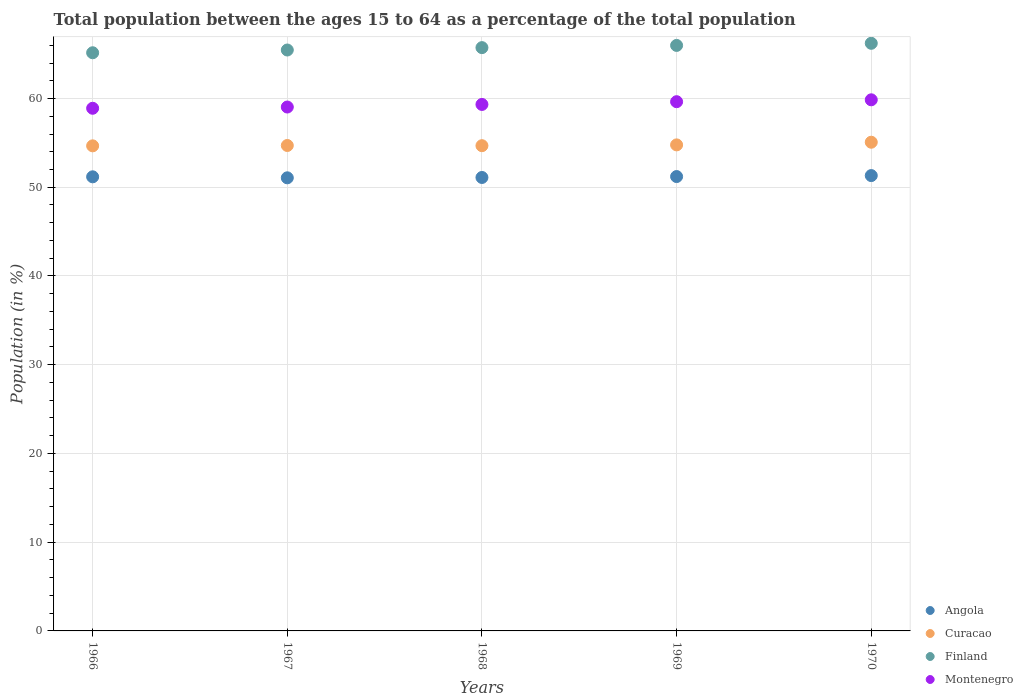How many different coloured dotlines are there?
Provide a short and direct response. 4. What is the percentage of the population ages 15 to 64 in Angola in 1967?
Your answer should be compact. 51.06. Across all years, what is the maximum percentage of the population ages 15 to 64 in Montenegro?
Provide a short and direct response. 59.85. Across all years, what is the minimum percentage of the population ages 15 to 64 in Angola?
Ensure brevity in your answer.  51.06. In which year was the percentage of the population ages 15 to 64 in Angola maximum?
Offer a very short reply. 1970. In which year was the percentage of the population ages 15 to 64 in Finland minimum?
Your answer should be compact. 1966. What is the total percentage of the population ages 15 to 64 in Curacao in the graph?
Ensure brevity in your answer.  273.91. What is the difference between the percentage of the population ages 15 to 64 in Montenegro in 1968 and that in 1969?
Your response must be concise. -0.31. What is the difference between the percentage of the population ages 15 to 64 in Curacao in 1967 and the percentage of the population ages 15 to 64 in Finland in 1970?
Provide a succinct answer. -11.52. What is the average percentage of the population ages 15 to 64 in Curacao per year?
Provide a short and direct response. 54.78. In the year 1967, what is the difference between the percentage of the population ages 15 to 64 in Angola and percentage of the population ages 15 to 64 in Curacao?
Your response must be concise. -3.64. In how many years, is the percentage of the population ages 15 to 64 in Curacao greater than 62?
Your response must be concise. 0. What is the ratio of the percentage of the population ages 15 to 64 in Curacao in 1967 to that in 1970?
Offer a terse response. 0.99. Is the percentage of the population ages 15 to 64 in Montenegro in 1968 less than that in 1970?
Your response must be concise. Yes. What is the difference between the highest and the second highest percentage of the population ages 15 to 64 in Angola?
Provide a succinct answer. 0.11. What is the difference between the highest and the lowest percentage of the population ages 15 to 64 in Finland?
Keep it short and to the point. 1.07. In how many years, is the percentage of the population ages 15 to 64 in Curacao greater than the average percentage of the population ages 15 to 64 in Curacao taken over all years?
Your response must be concise. 1. Is it the case that in every year, the sum of the percentage of the population ages 15 to 64 in Finland and percentage of the population ages 15 to 64 in Angola  is greater than the sum of percentage of the population ages 15 to 64 in Curacao and percentage of the population ages 15 to 64 in Montenegro?
Offer a very short reply. Yes. Is it the case that in every year, the sum of the percentage of the population ages 15 to 64 in Angola and percentage of the population ages 15 to 64 in Finland  is greater than the percentage of the population ages 15 to 64 in Montenegro?
Your answer should be very brief. Yes. Does the percentage of the population ages 15 to 64 in Angola monotonically increase over the years?
Ensure brevity in your answer.  No. Is the percentage of the population ages 15 to 64 in Montenegro strictly greater than the percentage of the population ages 15 to 64 in Angola over the years?
Your answer should be compact. Yes. How many dotlines are there?
Keep it short and to the point. 4. How many years are there in the graph?
Provide a succinct answer. 5. What is the difference between two consecutive major ticks on the Y-axis?
Offer a terse response. 10. Does the graph contain any zero values?
Give a very brief answer. No. Does the graph contain grids?
Give a very brief answer. Yes. Where does the legend appear in the graph?
Your answer should be very brief. Bottom right. How many legend labels are there?
Provide a succinct answer. 4. What is the title of the graph?
Give a very brief answer. Total population between the ages 15 to 64 as a percentage of the total population. What is the Population (in %) in Angola in 1966?
Provide a succinct answer. 51.18. What is the Population (in %) in Curacao in 1966?
Your answer should be very brief. 54.67. What is the Population (in %) of Finland in 1966?
Keep it short and to the point. 65.16. What is the Population (in %) in Montenegro in 1966?
Your response must be concise. 58.9. What is the Population (in %) of Angola in 1967?
Make the answer very short. 51.06. What is the Population (in %) in Curacao in 1967?
Your answer should be compact. 54.71. What is the Population (in %) in Finland in 1967?
Your answer should be compact. 65.47. What is the Population (in %) of Montenegro in 1967?
Give a very brief answer. 59.04. What is the Population (in %) of Angola in 1968?
Offer a terse response. 51.1. What is the Population (in %) in Curacao in 1968?
Provide a succinct answer. 54.68. What is the Population (in %) of Finland in 1968?
Give a very brief answer. 65.74. What is the Population (in %) in Montenegro in 1968?
Provide a short and direct response. 59.33. What is the Population (in %) of Angola in 1969?
Provide a short and direct response. 51.21. What is the Population (in %) in Curacao in 1969?
Provide a succinct answer. 54.78. What is the Population (in %) of Finland in 1969?
Ensure brevity in your answer.  65.98. What is the Population (in %) in Montenegro in 1969?
Provide a succinct answer. 59.64. What is the Population (in %) in Angola in 1970?
Ensure brevity in your answer.  51.32. What is the Population (in %) of Curacao in 1970?
Provide a short and direct response. 55.07. What is the Population (in %) in Finland in 1970?
Keep it short and to the point. 66.22. What is the Population (in %) of Montenegro in 1970?
Offer a terse response. 59.85. Across all years, what is the maximum Population (in %) in Angola?
Your answer should be compact. 51.32. Across all years, what is the maximum Population (in %) in Curacao?
Give a very brief answer. 55.07. Across all years, what is the maximum Population (in %) in Finland?
Your response must be concise. 66.22. Across all years, what is the maximum Population (in %) of Montenegro?
Provide a succinct answer. 59.85. Across all years, what is the minimum Population (in %) of Angola?
Make the answer very short. 51.06. Across all years, what is the minimum Population (in %) in Curacao?
Offer a terse response. 54.67. Across all years, what is the minimum Population (in %) of Finland?
Give a very brief answer. 65.16. Across all years, what is the minimum Population (in %) of Montenegro?
Provide a short and direct response. 58.9. What is the total Population (in %) of Angola in the graph?
Your response must be concise. 255.86. What is the total Population (in %) in Curacao in the graph?
Keep it short and to the point. 273.91. What is the total Population (in %) of Finland in the graph?
Your answer should be compact. 328.57. What is the total Population (in %) in Montenegro in the graph?
Make the answer very short. 296.77. What is the difference between the Population (in %) of Angola in 1966 and that in 1967?
Provide a succinct answer. 0.11. What is the difference between the Population (in %) of Curacao in 1966 and that in 1967?
Your answer should be very brief. -0.04. What is the difference between the Population (in %) of Finland in 1966 and that in 1967?
Make the answer very short. -0.31. What is the difference between the Population (in %) in Montenegro in 1966 and that in 1967?
Ensure brevity in your answer.  -0.14. What is the difference between the Population (in %) of Angola in 1966 and that in 1968?
Your answer should be very brief. 0.07. What is the difference between the Population (in %) in Curacao in 1966 and that in 1968?
Offer a very short reply. -0.02. What is the difference between the Population (in %) in Finland in 1966 and that in 1968?
Keep it short and to the point. -0.58. What is the difference between the Population (in %) of Montenegro in 1966 and that in 1968?
Provide a short and direct response. -0.43. What is the difference between the Population (in %) of Angola in 1966 and that in 1969?
Provide a succinct answer. -0.03. What is the difference between the Population (in %) of Curacao in 1966 and that in 1969?
Ensure brevity in your answer.  -0.11. What is the difference between the Population (in %) of Finland in 1966 and that in 1969?
Your answer should be compact. -0.83. What is the difference between the Population (in %) of Montenegro in 1966 and that in 1969?
Provide a succinct answer. -0.74. What is the difference between the Population (in %) in Angola in 1966 and that in 1970?
Provide a short and direct response. -0.14. What is the difference between the Population (in %) of Curacao in 1966 and that in 1970?
Your response must be concise. -0.41. What is the difference between the Population (in %) in Finland in 1966 and that in 1970?
Keep it short and to the point. -1.07. What is the difference between the Population (in %) in Montenegro in 1966 and that in 1970?
Provide a short and direct response. -0.95. What is the difference between the Population (in %) in Angola in 1967 and that in 1968?
Make the answer very short. -0.04. What is the difference between the Population (in %) in Curacao in 1967 and that in 1968?
Provide a short and direct response. 0.02. What is the difference between the Population (in %) in Finland in 1967 and that in 1968?
Your answer should be very brief. -0.27. What is the difference between the Population (in %) of Montenegro in 1967 and that in 1968?
Provide a succinct answer. -0.29. What is the difference between the Population (in %) of Angola in 1967 and that in 1969?
Your answer should be compact. -0.14. What is the difference between the Population (in %) in Curacao in 1967 and that in 1969?
Make the answer very short. -0.07. What is the difference between the Population (in %) in Finland in 1967 and that in 1969?
Keep it short and to the point. -0.52. What is the difference between the Population (in %) in Montenegro in 1967 and that in 1969?
Your answer should be very brief. -0.6. What is the difference between the Population (in %) of Angola in 1967 and that in 1970?
Give a very brief answer. -0.25. What is the difference between the Population (in %) of Curacao in 1967 and that in 1970?
Your answer should be very brief. -0.37. What is the difference between the Population (in %) of Finland in 1967 and that in 1970?
Give a very brief answer. -0.76. What is the difference between the Population (in %) in Montenegro in 1967 and that in 1970?
Ensure brevity in your answer.  -0.81. What is the difference between the Population (in %) of Angola in 1968 and that in 1969?
Make the answer very short. -0.1. What is the difference between the Population (in %) of Curacao in 1968 and that in 1969?
Give a very brief answer. -0.09. What is the difference between the Population (in %) of Finland in 1968 and that in 1969?
Make the answer very short. -0.25. What is the difference between the Population (in %) of Montenegro in 1968 and that in 1969?
Keep it short and to the point. -0.31. What is the difference between the Population (in %) in Angola in 1968 and that in 1970?
Your answer should be compact. -0.21. What is the difference between the Population (in %) in Curacao in 1968 and that in 1970?
Offer a terse response. -0.39. What is the difference between the Population (in %) in Finland in 1968 and that in 1970?
Your answer should be compact. -0.49. What is the difference between the Population (in %) of Montenegro in 1968 and that in 1970?
Ensure brevity in your answer.  -0.52. What is the difference between the Population (in %) in Angola in 1969 and that in 1970?
Offer a terse response. -0.11. What is the difference between the Population (in %) in Curacao in 1969 and that in 1970?
Your response must be concise. -0.3. What is the difference between the Population (in %) in Finland in 1969 and that in 1970?
Make the answer very short. -0.24. What is the difference between the Population (in %) in Montenegro in 1969 and that in 1970?
Provide a succinct answer. -0.21. What is the difference between the Population (in %) of Angola in 1966 and the Population (in %) of Curacao in 1967?
Make the answer very short. -3.53. What is the difference between the Population (in %) in Angola in 1966 and the Population (in %) in Finland in 1967?
Provide a succinct answer. -14.29. What is the difference between the Population (in %) in Angola in 1966 and the Population (in %) in Montenegro in 1967?
Your response must be concise. -7.87. What is the difference between the Population (in %) in Curacao in 1966 and the Population (in %) in Finland in 1967?
Provide a short and direct response. -10.8. What is the difference between the Population (in %) of Curacao in 1966 and the Population (in %) of Montenegro in 1967?
Offer a very short reply. -4.37. What is the difference between the Population (in %) in Finland in 1966 and the Population (in %) in Montenegro in 1967?
Give a very brief answer. 6.12. What is the difference between the Population (in %) of Angola in 1966 and the Population (in %) of Curacao in 1968?
Provide a short and direct response. -3.51. What is the difference between the Population (in %) in Angola in 1966 and the Population (in %) in Finland in 1968?
Your response must be concise. -14.56. What is the difference between the Population (in %) in Angola in 1966 and the Population (in %) in Montenegro in 1968?
Keep it short and to the point. -8.16. What is the difference between the Population (in %) of Curacao in 1966 and the Population (in %) of Finland in 1968?
Your answer should be very brief. -11.07. What is the difference between the Population (in %) in Curacao in 1966 and the Population (in %) in Montenegro in 1968?
Your response must be concise. -4.67. What is the difference between the Population (in %) in Finland in 1966 and the Population (in %) in Montenegro in 1968?
Offer a terse response. 5.82. What is the difference between the Population (in %) of Angola in 1966 and the Population (in %) of Curacao in 1969?
Provide a short and direct response. -3.6. What is the difference between the Population (in %) in Angola in 1966 and the Population (in %) in Finland in 1969?
Ensure brevity in your answer.  -14.81. What is the difference between the Population (in %) in Angola in 1966 and the Population (in %) in Montenegro in 1969?
Offer a very short reply. -8.47. What is the difference between the Population (in %) in Curacao in 1966 and the Population (in %) in Finland in 1969?
Ensure brevity in your answer.  -11.32. What is the difference between the Population (in %) in Curacao in 1966 and the Population (in %) in Montenegro in 1969?
Keep it short and to the point. -4.97. What is the difference between the Population (in %) in Finland in 1966 and the Population (in %) in Montenegro in 1969?
Offer a terse response. 5.52. What is the difference between the Population (in %) in Angola in 1966 and the Population (in %) in Curacao in 1970?
Give a very brief answer. -3.9. What is the difference between the Population (in %) of Angola in 1966 and the Population (in %) of Finland in 1970?
Your answer should be very brief. -15.05. What is the difference between the Population (in %) of Angola in 1966 and the Population (in %) of Montenegro in 1970?
Keep it short and to the point. -8.68. What is the difference between the Population (in %) in Curacao in 1966 and the Population (in %) in Finland in 1970?
Your answer should be compact. -11.56. What is the difference between the Population (in %) in Curacao in 1966 and the Population (in %) in Montenegro in 1970?
Ensure brevity in your answer.  -5.19. What is the difference between the Population (in %) in Finland in 1966 and the Population (in %) in Montenegro in 1970?
Your answer should be very brief. 5.3. What is the difference between the Population (in %) of Angola in 1967 and the Population (in %) of Curacao in 1968?
Give a very brief answer. -3.62. What is the difference between the Population (in %) of Angola in 1967 and the Population (in %) of Finland in 1968?
Make the answer very short. -14.67. What is the difference between the Population (in %) in Angola in 1967 and the Population (in %) in Montenegro in 1968?
Your response must be concise. -8.27. What is the difference between the Population (in %) in Curacao in 1967 and the Population (in %) in Finland in 1968?
Keep it short and to the point. -11.03. What is the difference between the Population (in %) in Curacao in 1967 and the Population (in %) in Montenegro in 1968?
Offer a terse response. -4.63. What is the difference between the Population (in %) of Finland in 1967 and the Population (in %) of Montenegro in 1968?
Ensure brevity in your answer.  6.13. What is the difference between the Population (in %) in Angola in 1967 and the Population (in %) in Curacao in 1969?
Your answer should be compact. -3.71. What is the difference between the Population (in %) of Angola in 1967 and the Population (in %) of Finland in 1969?
Provide a succinct answer. -14.92. What is the difference between the Population (in %) in Angola in 1967 and the Population (in %) in Montenegro in 1969?
Give a very brief answer. -8.58. What is the difference between the Population (in %) in Curacao in 1967 and the Population (in %) in Finland in 1969?
Ensure brevity in your answer.  -11.28. What is the difference between the Population (in %) of Curacao in 1967 and the Population (in %) of Montenegro in 1969?
Make the answer very short. -4.94. What is the difference between the Population (in %) of Finland in 1967 and the Population (in %) of Montenegro in 1969?
Your answer should be compact. 5.83. What is the difference between the Population (in %) in Angola in 1967 and the Population (in %) in Curacao in 1970?
Offer a very short reply. -4.01. What is the difference between the Population (in %) of Angola in 1967 and the Population (in %) of Finland in 1970?
Provide a succinct answer. -15.16. What is the difference between the Population (in %) in Angola in 1967 and the Population (in %) in Montenegro in 1970?
Keep it short and to the point. -8.79. What is the difference between the Population (in %) in Curacao in 1967 and the Population (in %) in Finland in 1970?
Your answer should be compact. -11.52. What is the difference between the Population (in %) of Curacao in 1967 and the Population (in %) of Montenegro in 1970?
Your response must be concise. -5.15. What is the difference between the Population (in %) in Finland in 1967 and the Population (in %) in Montenegro in 1970?
Ensure brevity in your answer.  5.61. What is the difference between the Population (in %) of Angola in 1968 and the Population (in %) of Curacao in 1969?
Keep it short and to the point. -3.67. What is the difference between the Population (in %) of Angola in 1968 and the Population (in %) of Finland in 1969?
Ensure brevity in your answer.  -14.88. What is the difference between the Population (in %) of Angola in 1968 and the Population (in %) of Montenegro in 1969?
Your response must be concise. -8.54. What is the difference between the Population (in %) of Curacao in 1968 and the Population (in %) of Finland in 1969?
Your answer should be compact. -11.3. What is the difference between the Population (in %) in Curacao in 1968 and the Population (in %) in Montenegro in 1969?
Your answer should be very brief. -4.96. What is the difference between the Population (in %) of Finland in 1968 and the Population (in %) of Montenegro in 1969?
Keep it short and to the point. 6.09. What is the difference between the Population (in %) of Angola in 1968 and the Population (in %) of Curacao in 1970?
Your response must be concise. -3.97. What is the difference between the Population (in %) in Angola in 1968 and the Population (in %) in Finland in 1970?
Offer a very short reply. -15.12. What is the difference between the Population (in %) of Angola in 1968 and the Population (in %) of Montenegro in 1970?
Your answer should be very brief. -8.75. What is the difference between the Population (in %) of Curacao in 1968 and the Population (in %) of Finland in 1970?
Provide a succinct answer. -11.54. What is the difference between the Population (in %) in Curacao in 1968 and the Population (in %) in Montenegro in 1970?
Provide a succinct answer. -5.17. What is the difference between the Population (in %) of Finland in 1968 and the Population (in %) of Montenegro in 1970?
Provide a short and direct response. 5.88. What is the difference between the Population (in %) in Angola in 1969 and the Population (in %) in Curacao in 1970?
Your answer should be compact. -3.87. What is the difference between the Population (in %) of Angola in 1969 and the Population (in %) of Finland in 1970?
Offer a terse response. -15.02. What is the difference between the Population (in %) of Angola in 1969 and the Population (in %) of Montenegro in 1970?
Keep it short and to the point. -8.65. What is the difference between the Population (in %) in Curacao in 1969 and the Population (in %) in Finland in 1970?
Your response must be concise. -11.45. What is the difference between the Population (in %) of Curacao in 1969 and the Population (in %) of Montenegro in 1970?
Ensure brevity in your answer.  -5.08. What is the difference between the Population (in %) in Finland in 1969 and the Population (in %) in Montenegro in 1970?
Provide a succinct answer. 6.13. What is the average Population (in %) in Angola per year?
Your response must be concise. 51.17. What is the average Population (in %) of Curacao per year?
Your answer should be compact. 54.78. What is the average Population (in %) of Finland per year?
Keep it short and to the point. 65.71. What is the average Population (in %) in Montenegro per year?
Ensure brevity in your answer.  59.35. In the year 1966, what is the difference between the Population (in %) of Angola and Population (in %) of Curacao?
Keep it short and to the point. -3.49. In the year 1966, what is the difference between the Population (in %) in Angola and Population (in %) in Finland?
Give a very brief answer. -13.98. In the year 1966, what is the difference between the Population (in %) of Angola and Population (in %) of Montenegro?
Ensure brevity in your answer.  -7.72. In the year 1966, what is the difference between the Population (in %) of Curacao and Population (in %) of Finland?
Make the answer very short. -10.49. In the year 1966, what is the difference between the Population (in %) of Curacao and Population (in %) of Montenegro?
Make the answer very short. -4.23. In the year 1966, what is the difference between the Population (in %) of Finland and Population (in %) of Montenegro?
Offer a terse response. 6.26. In the year 1967, what is the difference between the Population (in %) of Angola and Population (in %) of Curacao?
Your answer should be very brief. -3.64. In the year 1967, what is the difference between the Population (in %) in Angola and Population (in %) in Finland?
Your answer should be compact. -14.4. In the year 1967, what is the difference between the Population (in %) in Angola and Population (in %) in Montenegro?
Your response must be concise. -7.98. In the year 1967, what is the difference between the Population (in %) of Curacao and Population (in %) of Finland?
Ensure brevity in your answer.  -10.76. In the year 1967, what is the difference between the Population (in %) of Curacao and Population (in %) of Montenegro?
Your answer should be compact. -4.33. In the year 1967, what is the difference between the Population (in %) of Finland and Population (in %) of Montenegro?
Make the answer very short. 6.43. In the year 1968, what is the difference between the Population (in %) in Angola and Population (in %) in Curacao?
Keep it short and to the point. -3.58. In the year 1968, what is the difference between the Population (in %) in Angola and Population (in %) in Finland?
Your response must be concise. -14.63. In the year 1968, what is the difference between the Population (in %) of Angola and Population (in %) of Montenegro?
Ensure brevity in your answer.  -8.23. In the year 1968, what is the difference between the Population (in %) in Curacao and Population (in %) in Finland?
Offer a very short reply. -11.05. In the year 1968, what is the difference between the Population (in %) of Curacao and Population (in %) of Montenegro?
Your answer should be very brief. -4.65. In the year 1968, what is the difference between the Population (in %) of Finland and Population (in %) of Montenegro?
Your response must be concise. 6.4. In the year 1969, what is the difference between the Population (in %) in Angola and Population (in %) in Curacao?
Offer a terse response. -3.57. In the year 1969, what is the difference between the Population (in %) of Angola and Population (in %) of Finland?
Make the answer very short. -14.78. In the year 1969, what is the difference between the Population (in %) of Angola and Population (in %) of Montenegro?
Your response must be concise. -8.44. In the year 1969, what is the difference between the Population (in %) in Curacao and Population (in %) in Finland?
Your response must be concise. -11.21. In the year 1969, what is the difference between the Population (in %) of Curacao and Population (in %) of Montenegro?
Give a very brief answer. -4.87. In the year 1969, what is the difference between the Population (in %) of Finland and Population (in %) of Montenegro?
Offer a very short reply. 6.34. In the year 1970, what is the difference between the Population (in %) in Angola and Population (in %) in Curacao?
Offer a very short reply. -3.76. In the year 1970, what is the difference between the Population (in %) of Angola and Population (in %) of Finland?
Your response must be concise. -14.91. In the year 1970, what is the difference between the Population (in %) in Angola and Population (in %) in Montenegro?
Give a very brief answer. -8.54. In the year 1970, what is the difference between the Population (in %) of Curacao and Population (in %) of Finland?
Give a very brief answer. -11.15. In the year 1970, what is the difference between the Population (in %) in Curacao and Population (in %) in Montenegro?
Give a very brief answer. -4.78. In the year 1970, what is the difference between the Population (in %) in Finland and Population (in %) in Montenegro?
Offer a terse response. 6.37. What is the ratio of the Population (in %) of Montenegro in 1966 to that in 1967?
Give a very brief answer. 1. What is the ratio of the Population (in %) in Angola in 1966 to that in 1969?
Your response must be concise. 1. What is the ratio of the Population (in %) in Finland in 1966 to that in 1969?
Your answer should be very brief. 0.99. What is the ratio of the Population (in %) in Montenegro in 1966 to that in 1969?
Provide a succinct answer. 0.99. What is the ratio of the Population (in %) in Angola in 1966 to that in 1970?
Keep it short and to the point. 1. What is the ratio of the Population (in %) of Finland in 1966 to that in 1970?
Give a very brief answer. 0.98. What is the ratio of the Population (in %) of Montenegro in 1966 to that in 1970?
Your response must be concise. 0.98. What is the ratio of the Population (in %) of Finland in 1967 to that in 1968?
Provide a succinct answer. 1. What is the ratio of the Population (in %) of Angola in 1967 to that in 1969?
Provide a succinct answer. 1. What is the ratio of the Population (in %) in Finland in 1967 to that in 1969?
Offer a very short reply. 0.99. What is the ratio of the Population (in %) in Montenegro in 1967 to that in 1969?
Keep it short and to the point. 0.99. What is the ratio of the Population (in %) in Montenegro in 1967 to that in 1970?
Your answer should be compact. 0.99. What is the ratio of the Population (in %) of Angola in 1968 to that in 1969?
Your response must be concise. 1. What is the ratio of the Population (in %) of Curacao in 1968 to that in 1969?
Ensure brevity in your answer.  1. What is the ratio of the Population (in %) in Finland in 1968 to that in 1969?
Keep it short and to the point. 1. What is the ratio of the Population (in %) of Montenegro in 1968 to that in 1969?
Keep it short and to the point. 0.99. What is the ratio of the Population (in %) in Angola in 1968 to that in 1970?
Make the answer very short. 1. What is the ratio of the Population (in %) in Montenegro in 1968 to that in 1970?
Offer a very short reply. 0.99. What is the ratio of the Population (in %) in Angola in 1969 to that in 1970?
Your response must be concise. 1. What is the ratio of the Population (in %) of Curacao in 1969 to that in 1970?
Ensure brevity in your answer.  0.99. What is the ratio of the Population (in %) of Montenegro in 1969 to that in 1970?
Ensure brevity in your answer.  1. What is the difference between the highest and the second highest Population (in %) in Angola?
Offer a terse response. 0.11. What is the difference between the highest and the second highest Population (in %) of Curacao?
Provide a succinct answer. 0.3. What is the difference between the highest and the second highest Population (in %) of Finland?
Provide a short and direct response. 0.24. What is the difference between the highest and the second highest Population (in %) in Montenegro?
Your answer should be compact. 0.21. What is the difference between the highest and the lowest Population (in %) of Angola?
Provide a succinct answer. 0.25. What is the difference between the highest and the lowest Population (in %) in Curacao?
Provide a short and direct response. 0.41. What is the difference between the highest and the lowest Population (in %) of Finland?
Offer a terse response. 1.07. What is the difference between the highest and the lowest Population (in %) in Montenegro?
Your answer should be compact. 0.95. 